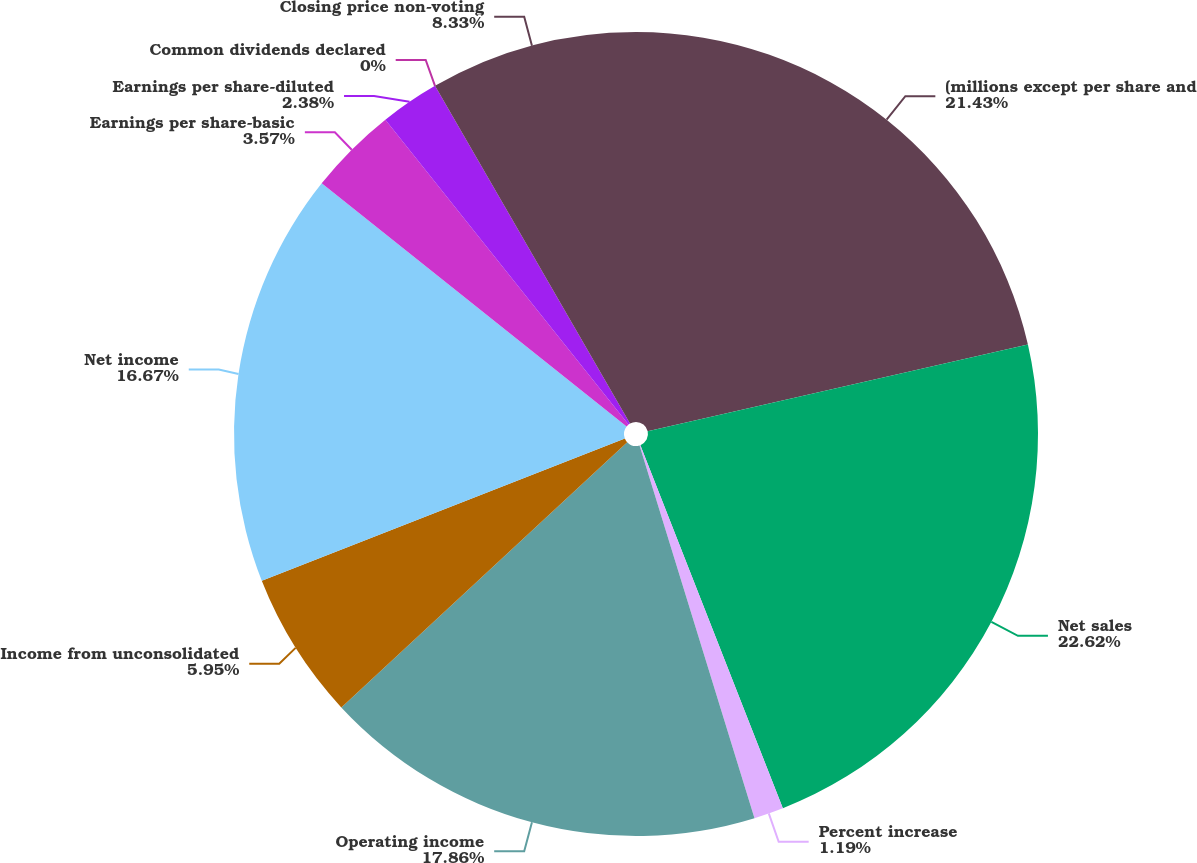Convert chart to OTSL. <chart><loc_0><loc_0><loc_500><loc_500><pie_chart><fcel>(millions except per share and<fcel>Net sales<fcel>Percent increase<fcel>Operating income<fcel>Income from unconsolidated<fcel>Net income<fcel>Earnings per share-basic<fcel>Earnings per share-diluted<fcel>Common dividends declared<fcel>Closing price non-voting<nl><fcel>21.42%<fcel>22.61%<fcel>1.19%<fcel>17.85%<fcel>5.95%<fcel>16.66%<fcel>3.57%<fcel>2.38%<fcel>0.0%<fcel>8.33%<nl></chart> 